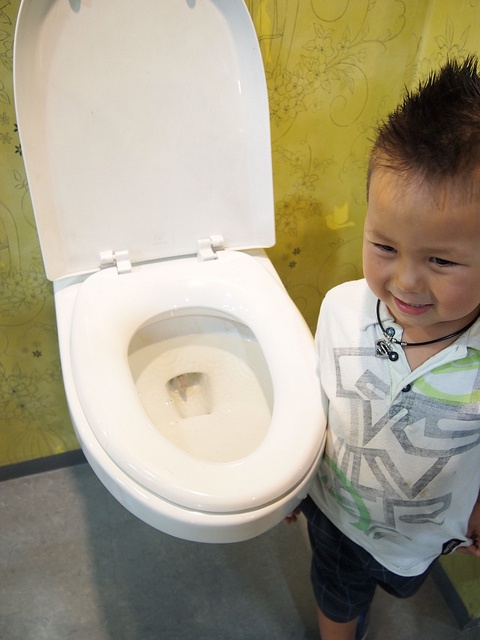Describe the objects in this image and their specific colors. I can see toilet in olive, lightgray, tan, and darkgray tones and people in olive, black, darkgray, and gray tones in this image. 